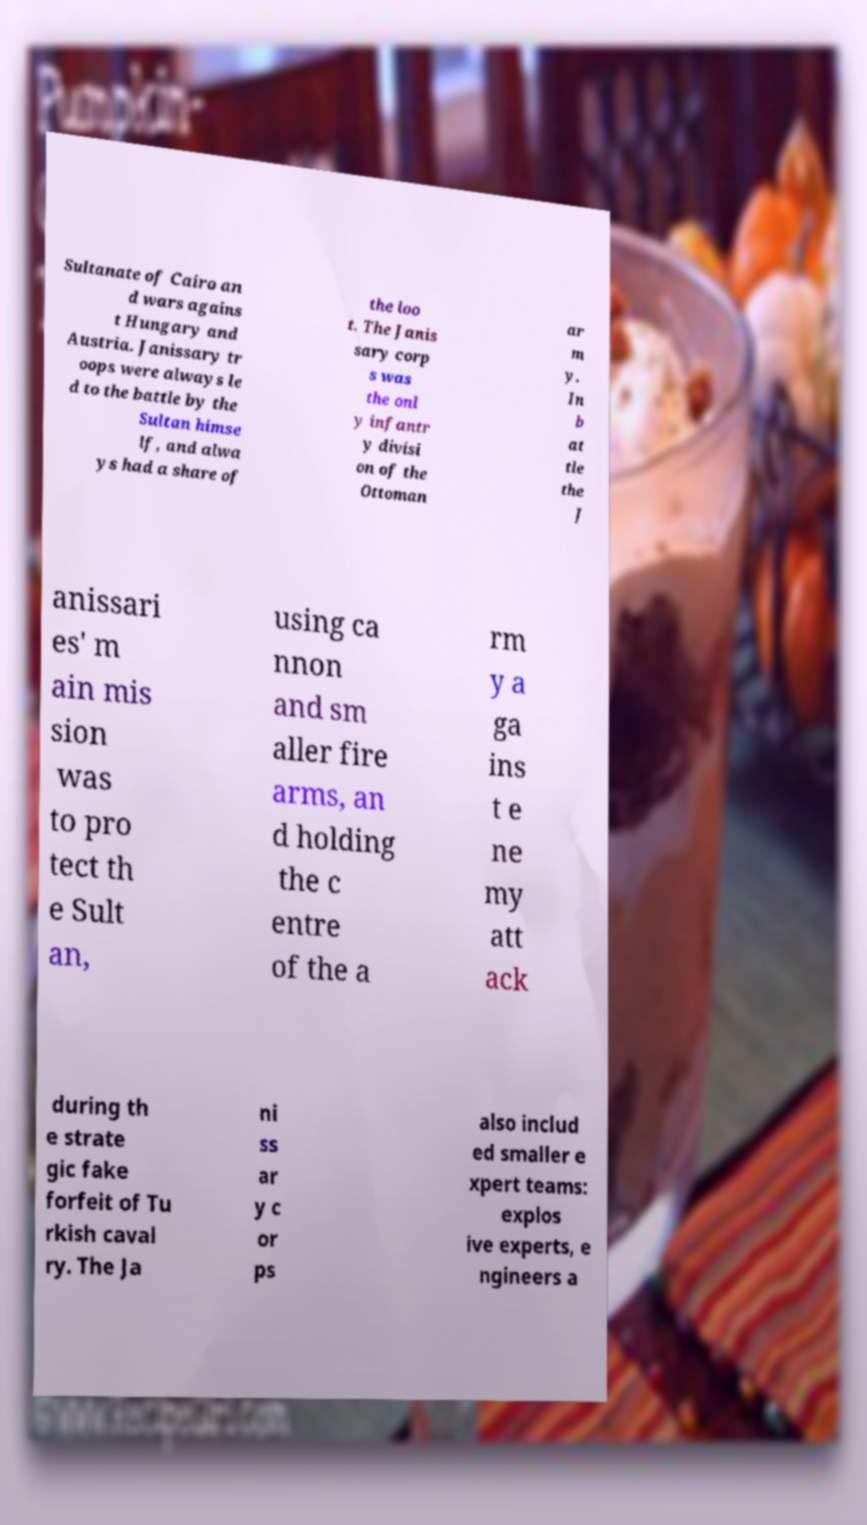Could you assist in decoding the text presented in this image and type it out clearly? Sultanate of Cairo an d wars agains t Hungary and Austria. Janissary tr oops were always le d to the battle by the Sultan himse lf, and alwa ys had a share of the loo t. The Janis sary corp s was the onl y infantr y divisi on of the Ottoman ar m y. In b at tle the J anissari es' m ain mis sion was to pro tect th e Sult an, using ca nnon and sm aller fire arms, an d holding the c entre of the a rm y a ga ins t e ne my att ack during th e strate gic fake forfeit of Tu rkish caval ry. The Ja ni ss ar y c or ps also includ ed smaller e xpert teams: explos ive experts, e ngineers a 